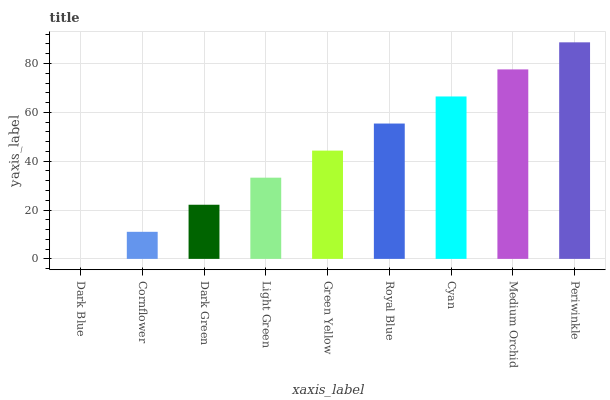Is Cornflower the minimum?
Answer yes or no. No. Is Cornflower the maximum?
Answer yes or no. No. Is Cornflower greater than Dark Blue?
Answer yes or no. Yes. Is Dark Blue less than Cornflower?
Answer yes or no. Yes. Is Dark Blue greater than Cornflower?
Answer yes or no. No. Is Cornflower less than Dark Blue?
Answer yes or no. No. Is Green Yellow the high median?
Answer yes or no. Yes. Is Green Yellow the low median?
Answer yes or no. Yes. Is Dark Blue the high median?
Answer yes or no. No. Is Light Green the low median?
Answer yes or no. No. 